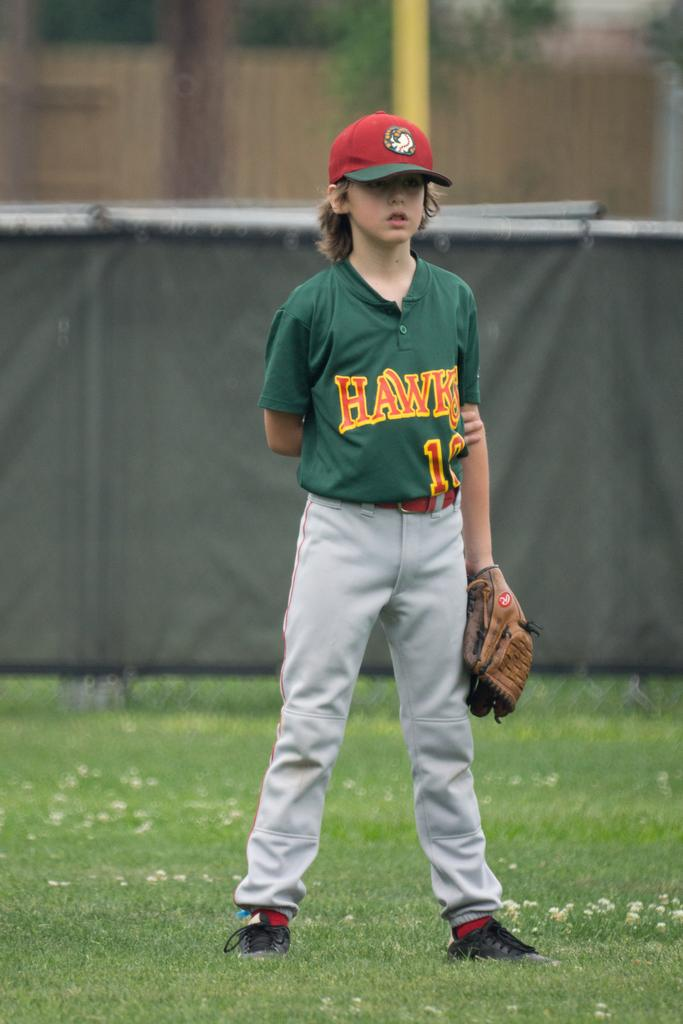<image>
Relay a brief, clear account of the picture shown. A young baseball player stands on the field wearing a green Hawks jersey/ 